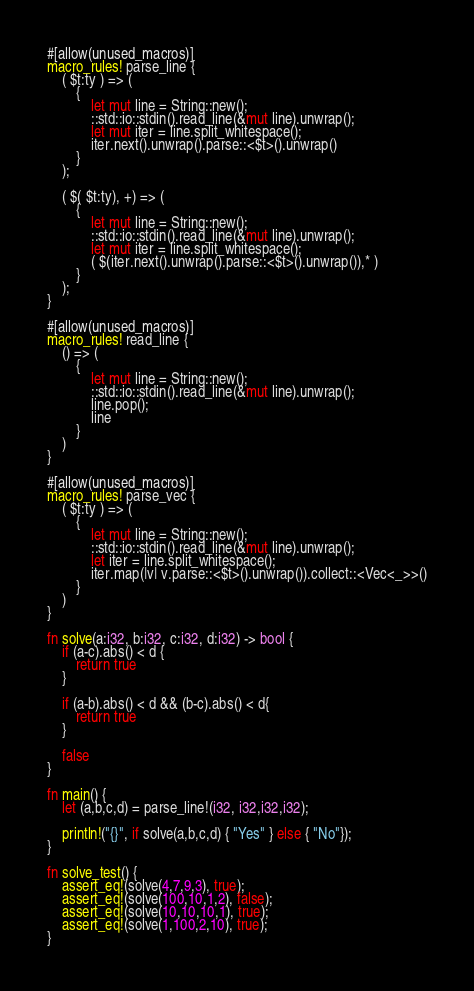Convert code to text. <code><loc_0><loc_0><loc_500><loc_500><_Rust_>#[allow(unused_macros)]
macro_rules! parse_line {
    ( $t:ty ) => (
        {
            let mut line = String::new();
            ::std::io::stdin().read_line(&mut line).unwrap();
            let mut iter = line.split_whitespace();
            iter.next().unwrap().parse::<$t>().unwrap()
        }
    );

    ( $( $t:ty), +) => (
        {
            let mut line = String::new();
            ::std::io::stdin().read_line(&mut line).unwrap();
            let mut iter = line.split_whitespace();
            ( $(iter.next().unwrap().parse::<$t>().unwrap()),* )
        }
    );
}

#[allow(unused_macros)]
macro_rules! read_line {
    () => (
        {
            let mut line = String::new();
            ::std::io::stdin().read_line(&mut line).unwrap();
            line.pop();
            line
        }
    )
}

#[allow(unused_macros)]
macro_rules! parse_vec {
    ( $t:ty ) => (
        {
            let mut line = String::new();
            ::std::io::stdin().read_line(&mut line).unwrap();
            let iter = line.split_whitespace();
            iter.map(|v| v.parse::<$t>().unwrap()).collect::<Vec<_>>()
        }
    )
}

fn solve(a:i32, b:i32, c:i32, d:i32) -> bool {
    if (a-c).abs() < d {
        return true
    }

    if (a-b).abs() < d && (b-c).abs() < d{
        return true
    }

    false
}

fn main() {
    let (a,b,c,d) = parse_line!(i32, i32,i32,i32);

    println!("{}", if solve(a,b,c,d) { "Yes" } else { "No"});
}

fn solve_test() {
    assert_eq!(solve(4,7,9,3), true);
    assert_eq!(solve(100,10,1,2), false);
    assert_eq!(solve(10,10,10,1), true);
    assert_eq!(solve(1,100,2,10), true);
}
</code> 